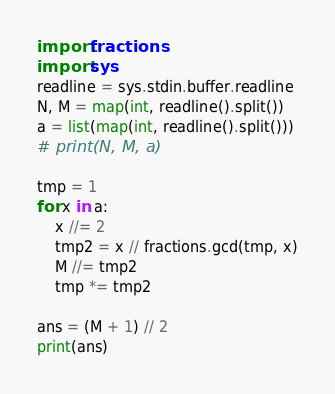Convert code to text. <code><loc_0><loc_0><loc_500><loc_500><_Python_>import fractions
import sys
readline = sys.stdin.buffer.readline
N, M = map(int, readline().split())
a = list(map(int, readline().split()))
# print(N, M, a)

tmp = 1
for x in a:
    x //= 2
    tmp2 = x // fractions.gcd(tmp, x)
    M //= tmp2
    tmp *= tmp2

ans = (M + 1) // 2
print(ans)
</code> 